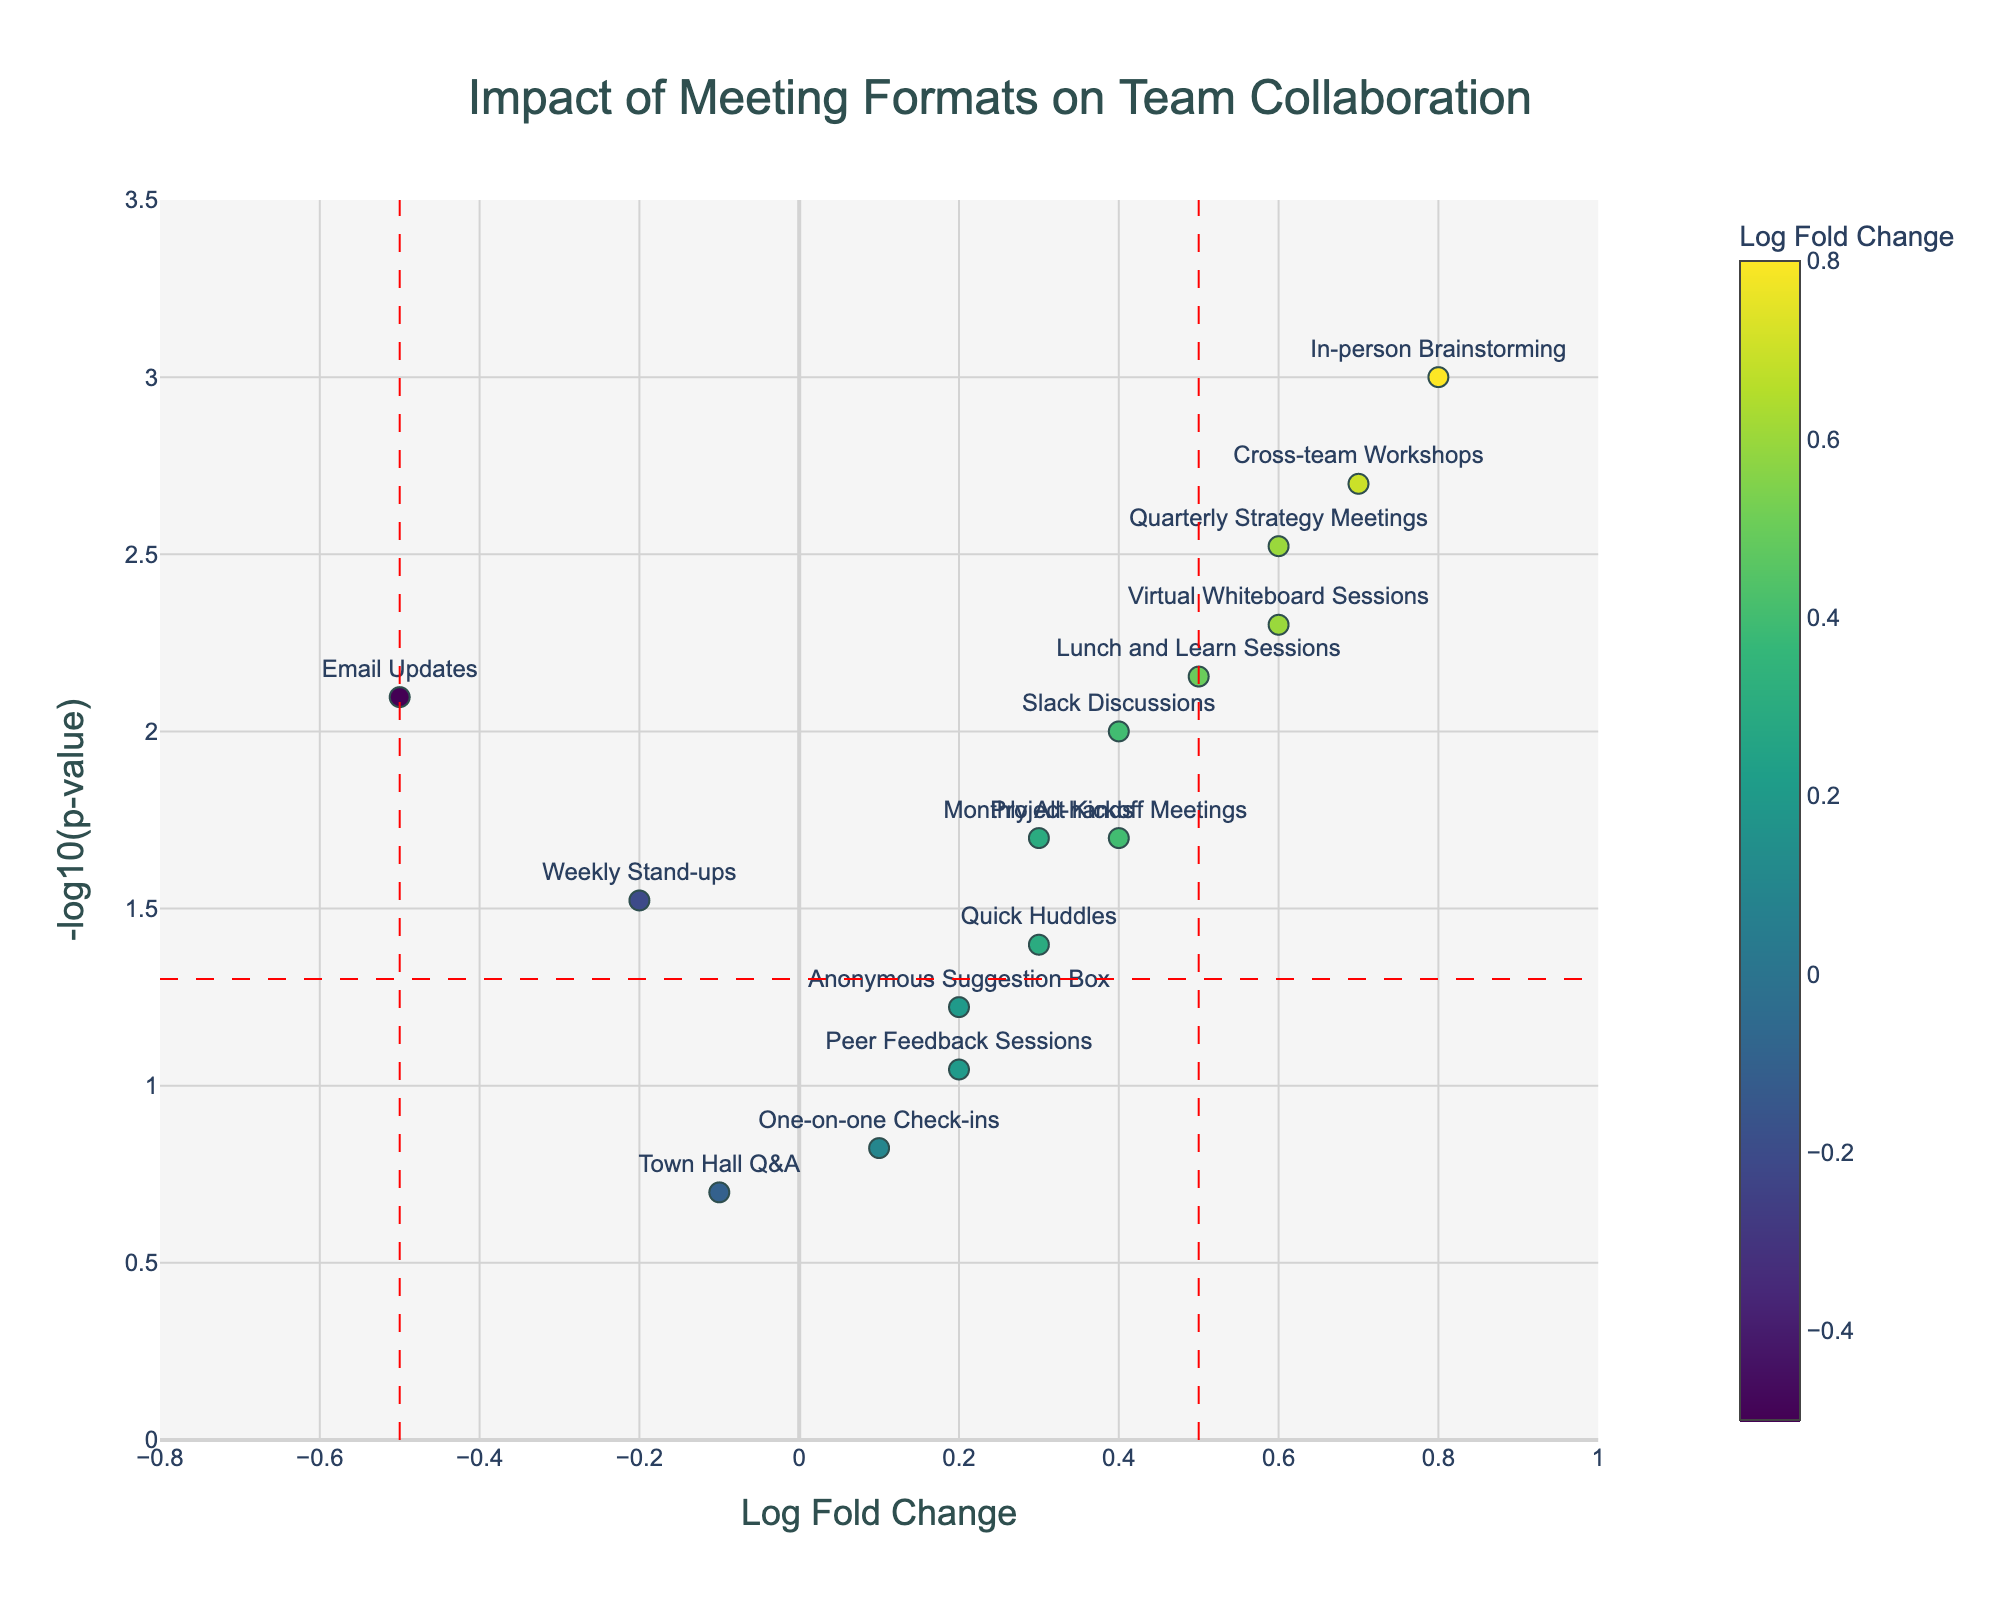What is the title of the plot? The title usually appears at the top of the plot in a larger or bold font, indicating what the figure is about. In this case, it is given in the code as "Impact of Meeting Formats on Team Collaboration."
Answer: Impact of Meeting Formats on Team Collaboration How many data points (meeting types) are shown in the plot? To find this, count the number of distinct markers or text annotations representing different meeting types on the plot. According to the data, there should be 15 points.
Answer: 15 Which meeting type has the highest -log10(p-value)? Look at the y-axis representing -log10(p-value) and identify the marker that reaches the highest point. According to the data, "In-person Brainstorming" has the lowest p-value, hence the highest -log10(p-value).
Answer: In-person Brainstorming Which meeting types have a statistically significant impact on team collaboration (p-value < 0.05)? Statistically significant points are those above the horizontal red dashed line, equivalent to -log10(0.05). Based on the data, the significant meeting types are: In-person Brainstorming, Virtual Whiteboard Sessions, Monthly All-hands, Email Updates, Slack Discussions, Cross-team Workshops, Lunch and Learn Sessions, Quarterly Strategy Meetings, and Project Kickoff Meetings.
Answer: In-person Brainstorming, Virtual Whiteboard Sessions, Monthly All-hands, Email Updates, Slack Discussions, Cross-team Workshops, Lunch and Learn Sessions, Quarterly Strategy Meetings, Project Kickoff Meetings Which meeting type has the smallest positive log fold change, and what is its p-value? Look for the smallest positive value on the x-axis to the right of zero. The corresponding marker and its hover text will provide the meeting type and its p-value. Based on the data, "One-on-one Check-ins" has a log fold change of 0.1.
Answer: One-on-one Check-ins, 0.15 Are there any meeting types with negative log fold change and statistically significant impact (p-value < 0.05)? Identify markers to the left of zero on the x-axis and above the horizontal red dashed line. According to the data, "Email Updates" meets these criteria.
Answer: Email Updates What is the range of log fold change values represented in the plot? Check the x-axis range to identify the minimum and maximum values depicted in the plot. The plot ranges approximately from -0.8 to 1 based on the figure settings in the code.
Answer: -0.8 to 1 How does the collaboration impact of "Weekly Stand-ups" compare to "Quick Huddles"? Compare their positions on the x and y axes. "Weekly Stand-ups" has a log fold change of -0.2 and a -log10(p-value) just above 1.1, while "Quick Huddles" has a log fold change of 0.3 and a -log10(p-value) around 1.4.
Answer: Weekly Stand-ups have a lower log fold change and higher p-value than Quick Huddles Which two meeting types are closest to each other on the plot, and what are their log fold changes? Look at which markers are nearest in proximity on the plot, indicating similar log fold changes and p-values. "Quick Huddles" and "Monthly All-hands" are close to each other in terms of proximity. Their log fold changes are 0.3 for both.
Answer: Quick Huddles and Monthly All-hands, both 0.3 